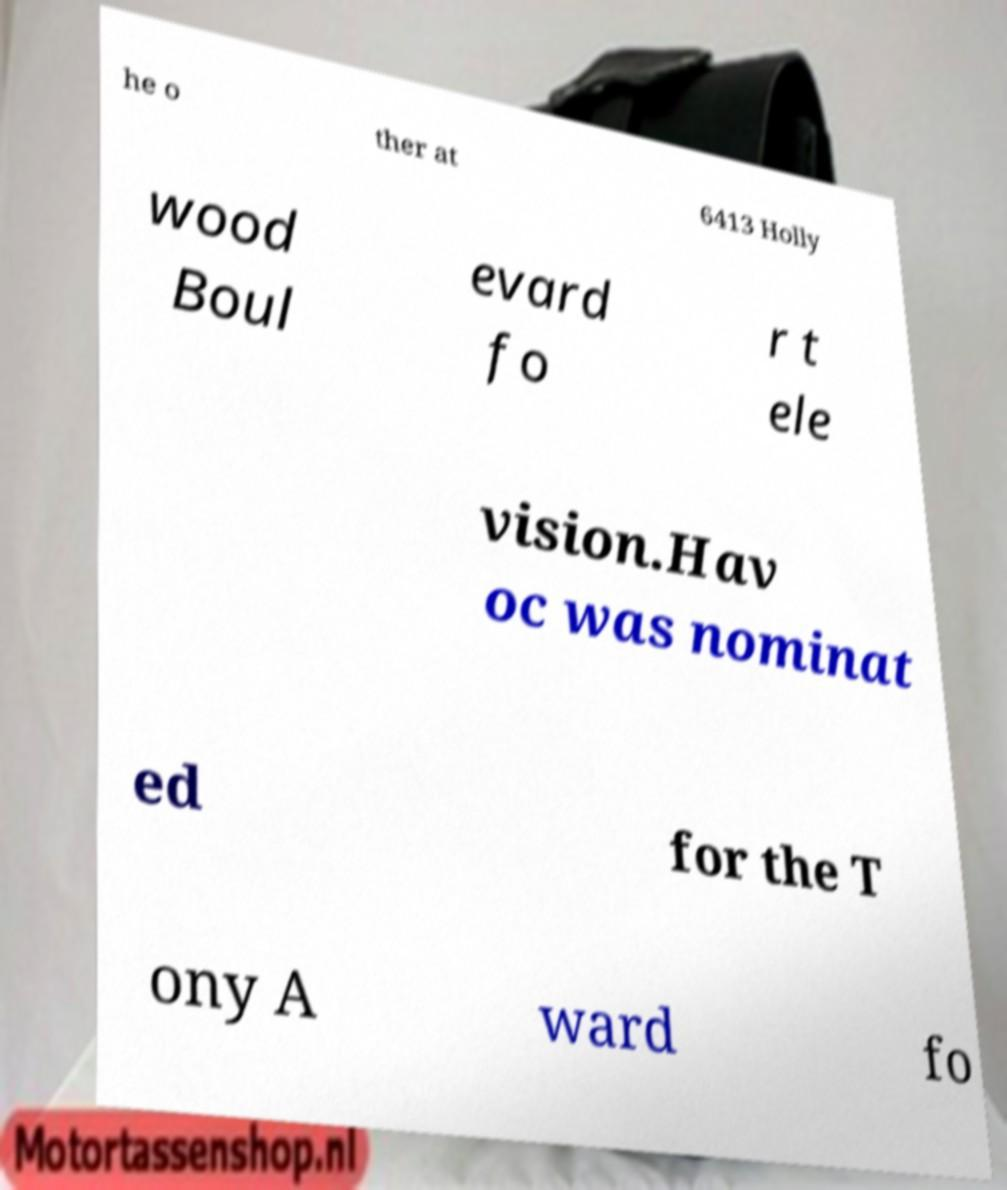I need the written content from this picture converted into text. Can you do that? he o ther at 6413 Holly wood Boul evard fo r t ele vision.Hav oc was nominat ed for the T ony A ward fo 